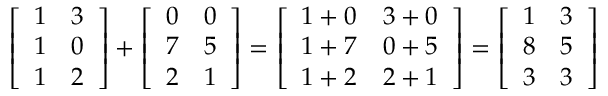<formula> <loc_0><loc_0><loc_500><loc_500>{ \left [ \begin{array} { l l } { 1 } & { 3 } \\ { 1 } & { 0 } \\ { 1 } & { 2 } \end{array} \right ] } + { \left [ \begin{array} { l l } { 0 } & { 0 } \\ { 7 } & { 5 } \\ { 2 } & { 1 } \end{array} \right ] } = { \left [ \begin{array} { l l } { 1 + 0 } & { 3 + 0 } \\ { 1 + 7 } & { 0 + 5 } \\ { 1 + 2 } & { 2 + 1 } \end{array} \right ] } = { \left [ \begin{array} { l l } { 1 } & { 3 } \\ { 8 } & { 5 } \\ { 3 } & { 3 } \end{array} \right ] }</formula> 